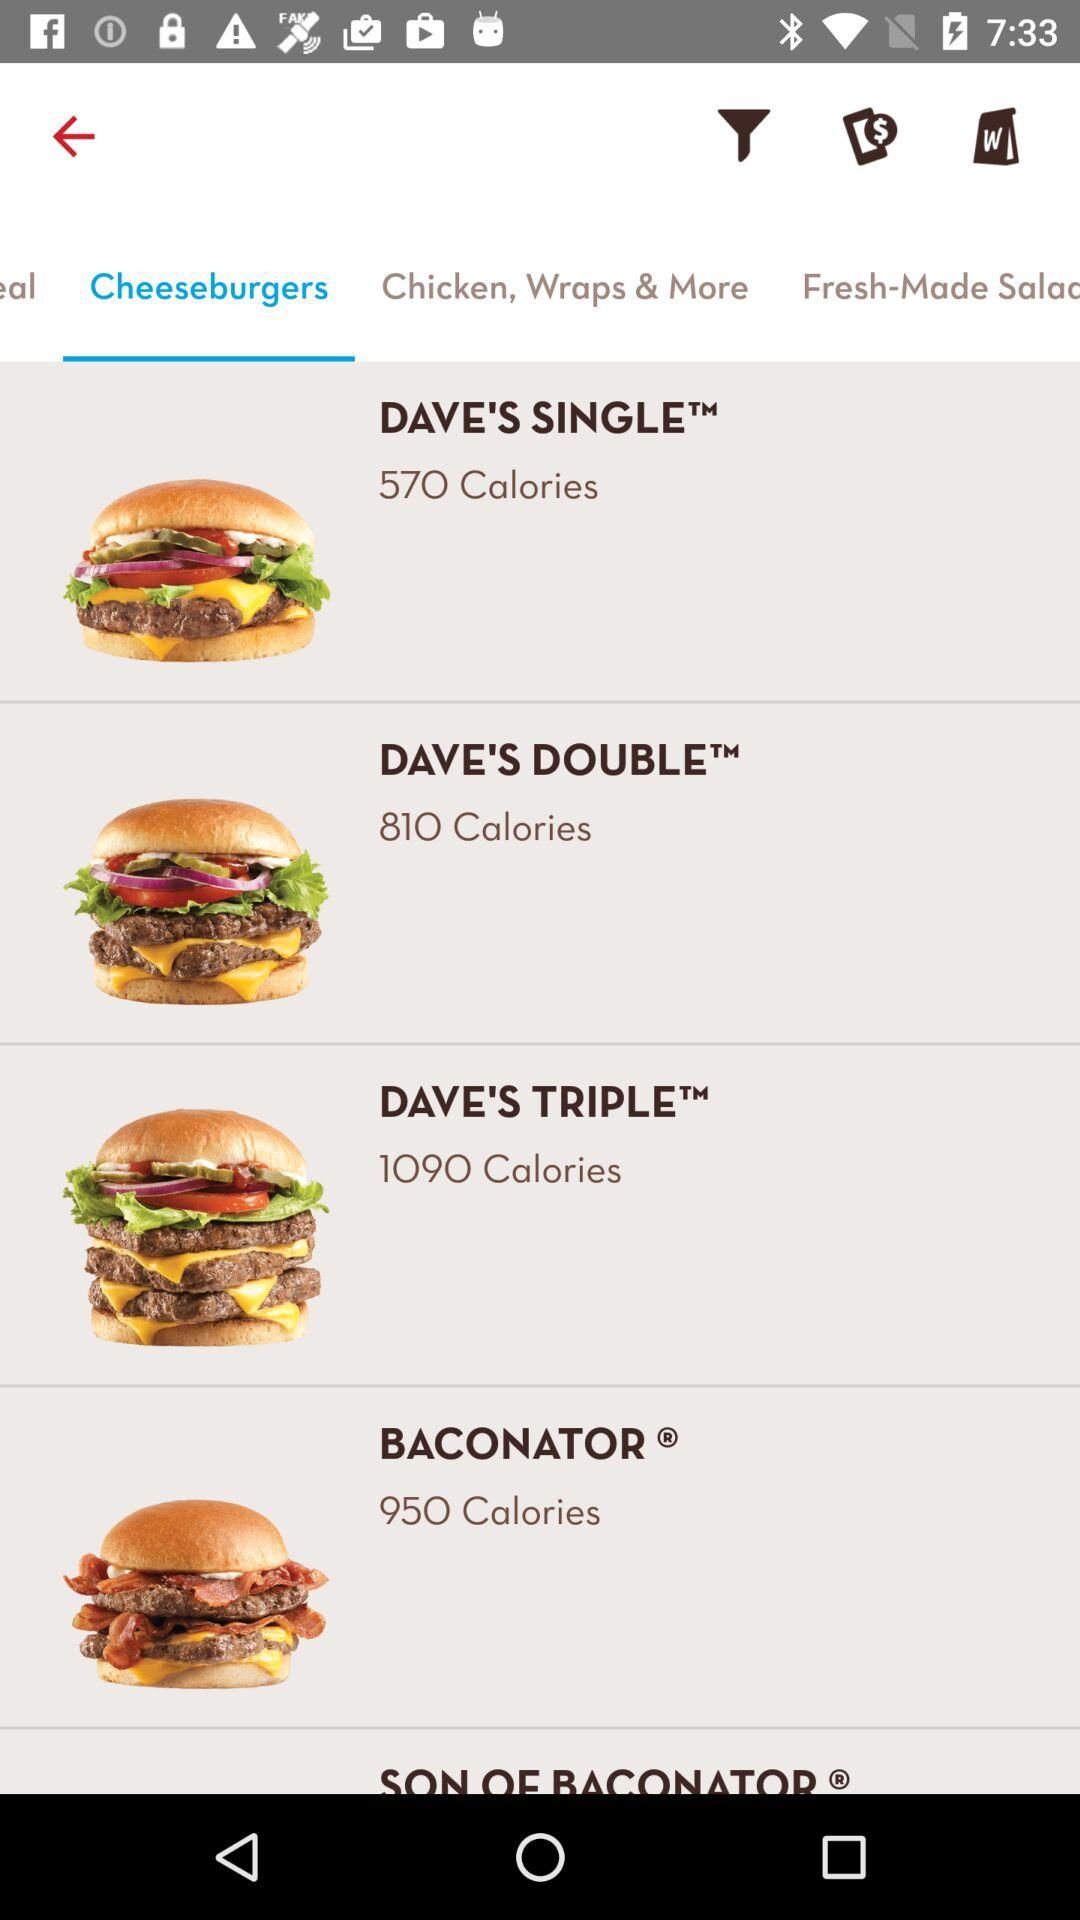How many more calories are in the Dave's Triple than the Dave's Single?
Answer the question using a single word or phrase. 520 